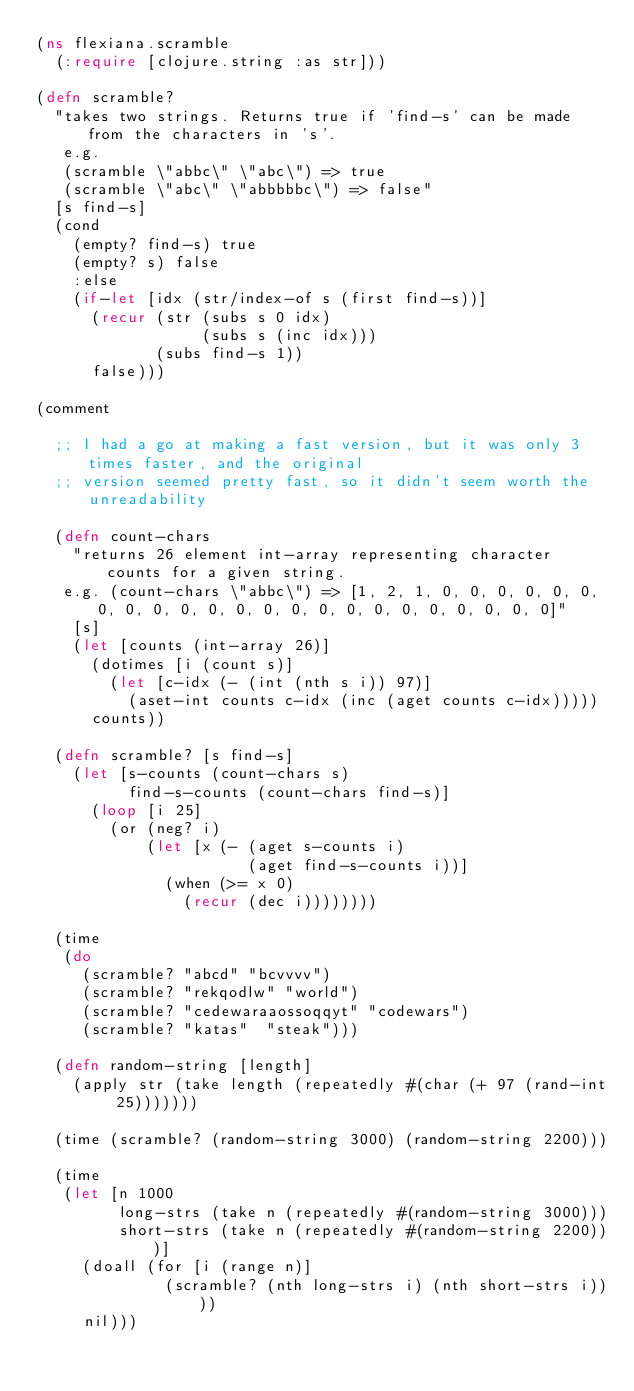<code> <loc_0><loc_0><loc_500><loc_500><_Clojure_>(ns flexiana.scramble
  (:require [clojure.string :as str]))

(defn scramble? 
  "takes two strings. Returns true if 'find-s' can be made from the characters in 's'.
   e.g.
   (scramble \"abbc\" \"abc\") => true
   (scramble \"abc\" \"abbbbbc\") => false"
  [s find-s]
  (cond
    (empty? find-s) true
    (empty? s) false
    :else
    (if-let [idx (str/index-of s (first find-s))]      
      (recur (str (subs s 0 idx)
                  (subs s (inc idx)))
             (subs find-s 1))
      false)))

(comment

  ;; I had a go at making a fast version, but it was only 3 times faster, and the original
  ;; version seemed pretty fast, so it didn't seem worth the unreadability
  
  (defn count-chars
    "returns 26 element int-array representing character counts for a given string.
   e.g. (count-chars \"abbc\") => [1, 2, 1, 0, 0, 0, 0, 0, 0, 0, 0, 0, 0, 0, 0, 0, 0, 0, 0, 0, 0, 0, 0, 0, 0, 0]"
    [s]
    (let [counts (int-array 26)]
      (dotimes [i (count s)]
        (let [c-idx (- (int (nth s i)) 97)]
          (aset-int counts c-idx (inc (aget counts c-idx)))))
      counts))

  (defn scramble? [s find-s]
    (let [s-counts (count-chars s)
          find-s-counts (count-chars find-s)]
      (loop [i 25]
        (or (neg? i)
            (let [x (- (aget s-counts i)
                       (aget find-s-counts i))]
              (when (>= x 0)
                (recur (dec i))))))))

  (time 
   (do
     (scramble? "abcd" "bcvvvv")
     (scramble? "rekqodlw" "world")
     (scramble? "cedewaraaossoqqyt" "codewars")
     (scramble? "katas"  "steak")))

  (defn random-string [length]
    (apply str (take length (repeatedly #(char (+ 97 (rand-int 25)))))))

  (time (scramble? (random-string 3000) (random-string 2200)))

  (time
   (let [n 1000
         long-strs (take n (repeatedly #(random-string 3000)))
         short-strs (take n (repeatedly #(random-string 2200)))]
     (doall (for [i (range n)]
              (scramble? (nth long-strs i) (nth short-strs i))))
     nil)))

</code> 